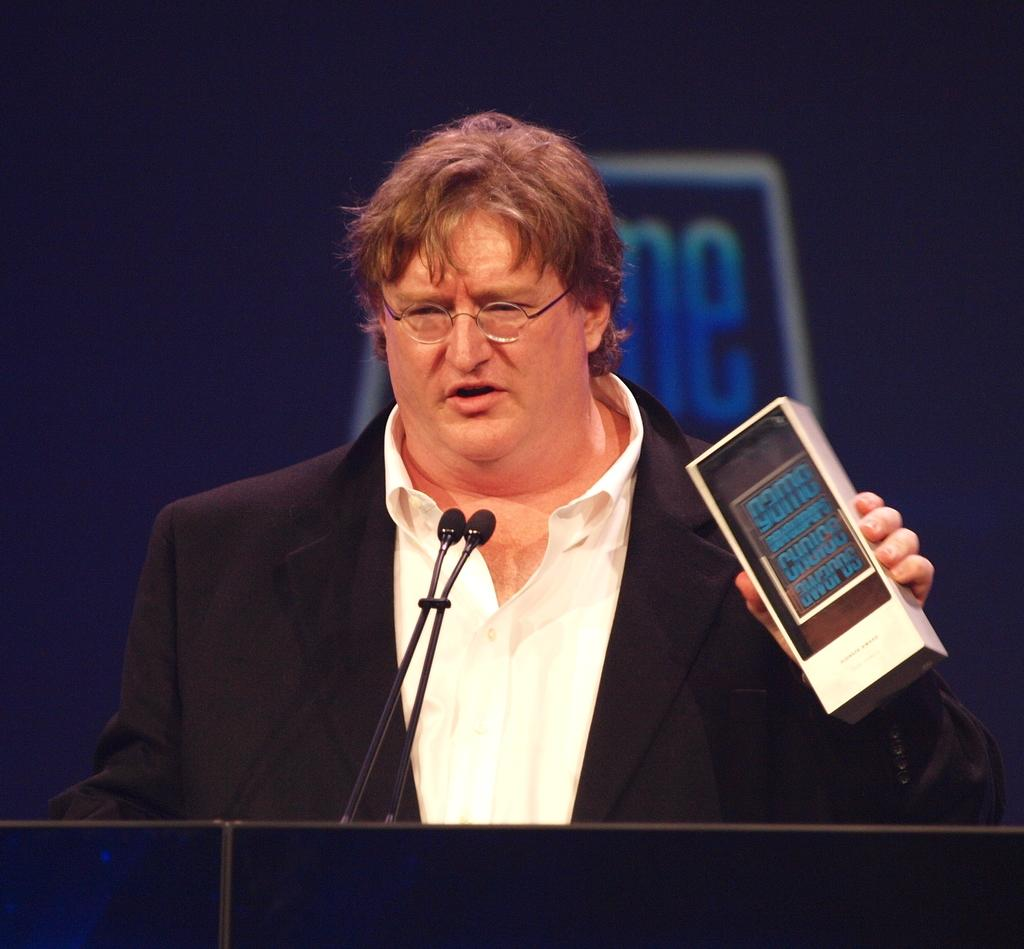What is the main subject of the image? The main subject of the image is a man. Can you describe the man's appearance? The man is wearing glasses (specs). What is the man holding in his hand? The man is holding something in his hand, but we cannot determine what it is from the image. What is in front of the man? There are microphones (mics) in front of the man. What color is the wall in the background of the image? There is a blue wall in the background of the image. What is on the blue wall? There is an object on the blue wall, but we cannot determine what it is from the image. Can you tell me how many cars are parked next to the river in the image? There is no river or cars present in the image; it features a man with microphones in front of him and a blue wall in the background. 